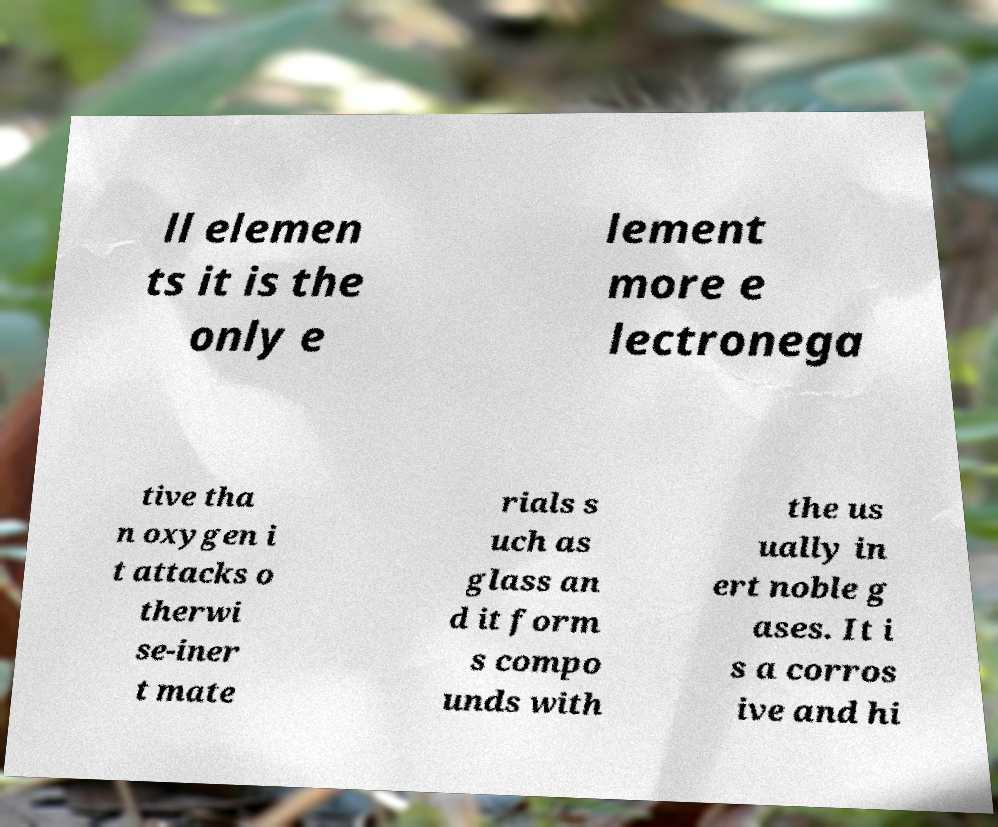Please read and relay the text visible in this image. What does it say? ll elemen ts it is the only e lement more e lectronega tive tha n oxygen i t attacks o therwi se-iner t mate rials s uch as glass an d it form s compo unds with the us ually in ert noble g ases. It i s a corros ive and hi 